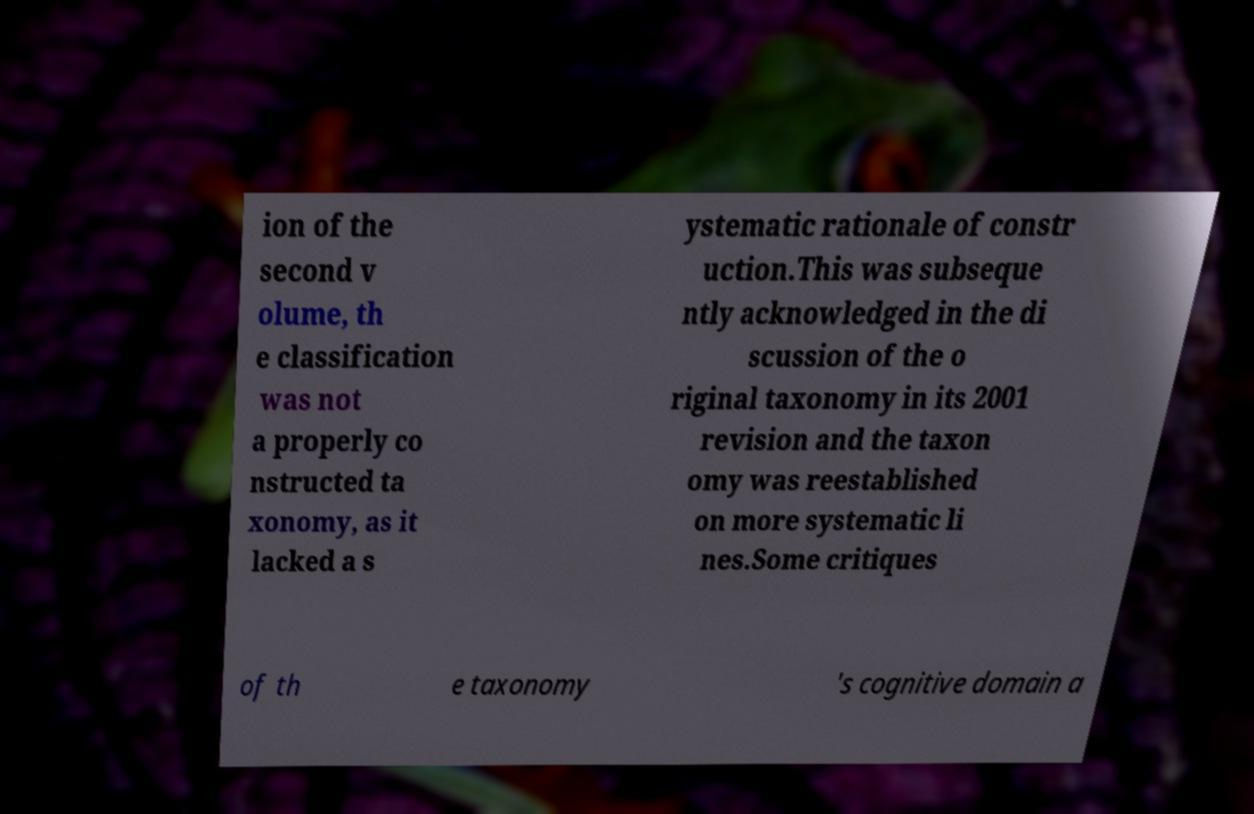Can you read and provide the text displayed in the image?This photo seems to have some interesting text. Can you extract and type it out for me? ion of the second v olume, th e classification was not a properly co nstructed ta xonomy, as it lacked a s ystematic rationale of constr uction.This was subseque ntly acknowledged in the di scussion of the o riginal taxonomy in its 2001 revision and the taxon omy was reestablished on more systematic li nes.Some critiques of th e taxonomy 's cognitive domain a 